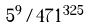<formula> <loc_0><loc_0><loc_500><loc_500>5 ^ { 9 } / 4 7 1 ^ { 3 2 5 }</formula> 